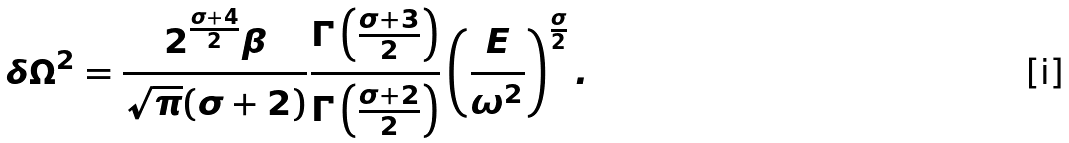Convert formula to latex. <formula><loc_0><loc_0><loc_500><loc_500>\delta \Omega ^ { 2 } = \frac { 2 ^ { \frac { \sigma + 4 } { 2 } } \beta } { \sqrt { \pi } ( \sigma + 2 ) } \frac { \Gamma \left ( \frac { \sigma + 3 } { 2 } \right ) } { \Gamma \left ( \frac { \sigma + 2 } { 2 } \right ) } \left ( \frac { E } { \omega ^ { 2 } } \right ) ^ { \frac { \sigma } { 2 } } .</formula> 